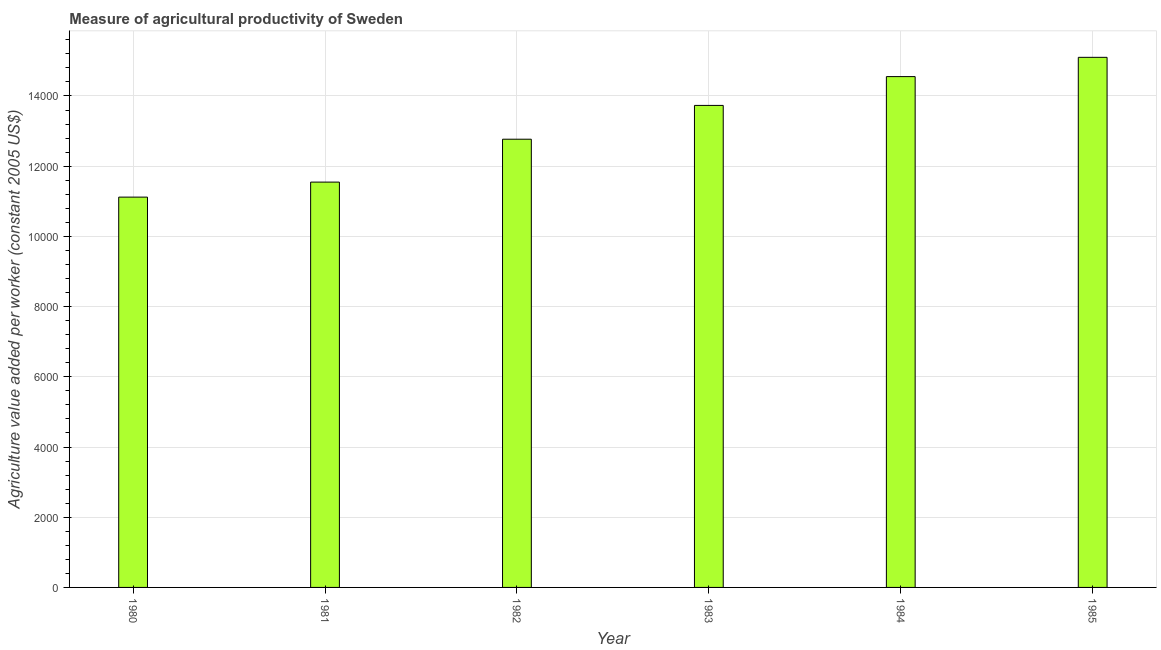What is the title of the graph?
Offer a very short reply. Measure of agricultural productivity of Sweden. What is the label or title of the Y-axis?
Give a very brief answer. Agriculture value added per worker (constant 2005 US$). What is the agriculture value added per worker in 1981?
Offer a terse response. 1.15e+04. Across all years, what is the maximum agriculture value added per worker?
Offer a very short reply. 1.51e+04. Across all years, what is the minimum agriculture value added per worker?
Your answer should be very brief. 1.11e+04. What is the sum of the agriculture value added per worker?
Give a very brief answer. 7.88e+04. What is the difference between the agriculture value added per worker in 1983 and 1985?
Provide a succinct answer. -1369.77. What is the average agriculture value added per worker per year?
Ensure brevity in your answer.  1.31e+04. What is the median agriculture value added per worker?
Make the answer very short. 1.32e+04. Do a majority of the years between 1984 and 1985 (inclusive) have agriculture value added per worker greater than 8400 US$?
Give a very brief answer. Yes. What is the ratio of the agriculture value added per worker in 1982 to that in 1985?
Offer a terse response. 0.85. What is the difference between the highest and the second highest agriculture value added per worker?
Give a very brief answer. 549.02. What is the difference between the highest and the lowest agriculture value added per worker?
Make the answer very short. 3982.16. In how many years, is the agriculture value added per worker greater than the average agriculture value added per worker taken over all years?
Your answer should be very brief. 3. What is the Agriculture value added per worker (constant 2005 US$) of 1980?
Offer a very short reply. 1.11e+04. What is the Agriculture value added per worker (constant 2005 US$) in 1981?
Your answer should be very brief. 1.15e+04. What is the Agriculture value added per worker (constant 2005 US$) of 1982?
Give a very brief answer. 1.28e+04. What is the Agriculture value added per worker (constant 2005 US$) of 1983?
Keep it short and to the point. 1.37e+04. What is the Agriculture value added per worker (constant 2005 US$) in 1984?
Your answer should be very brief. 1.46e+04. What is the Agriculture value added per worker (constant 2005 US$) in 1985?
Your response must be concise. 1.51e+04. What is the difference between the Agriculture value added per worker (constant 2005 US$) in 1980 and 1981?
Keep it short and to the point. -427.51. What is the difference between the Agriculture value added per worker (constant 2005 US$) in 1980 and 1982?
Your answer should be compact. -1649.43. What is the difference between the Agriculture value added per worker (constant 2005 US$) in 1980 and 1983?
Ensure brevity in your answer.  -2612.39. What is the difference between the Agriculture value added per worker (constant 2005 US$) in 1980 and 1984?
Keep it short and to the point. -3433.14. What is the difference between the Agriculture value added per worker (constant 2005 US$) in 1980 and 1985?
Provide a short and direct response. -3982.16. What is the difference between the Agriculture value added per worker (constant 2005 US$) in 1981 and 1982?
Your response must be concise. -1221.92. What is the difference between the Agriculture value added per worker (constant 2005 US$) in 1981 and 1983?
Make the answer very short. -2184.88. What is the difference between the Agriculture value added per worker (constant 2005 US$) in 1981 and 1984?
Provide a short and direct response. -3005.63. What is the difference between the Agriculture value added per worker (constant 2005 US$) in 1981 and 1985?
Provide a succinct answer. -3554.65. What is the difference between the Agriculture value added per worker (constant 2005 US$) in 1982 and 1983?
Offer a very short reply. -962.96. What is the difference between the Agriculture value added per worker (constant 2005 US$) in 1982 and 1984?
Your answer should be compact. -1783.71. What is the difference between the Agriculture value added per worker (constant 2005 US$) in 1982 and 1985?
Your answer should be very brief. -2332.73. What is the difference between the Agriculture value added per worker (constant 2005 US$) in 1983 and 1984?
Provide a succinct answer. -820.75. What is the difference between the Agriculture value added per worker (constant 2005 US$) in 1983 and 1985?
Provide a short and direct response. -1369.77. What is the difference between the Agriculture value added per worker (constant 2005 US$) in 1984 and 1985?
Keep it short and to the point. -549.02. What is the ratio of the Agriculture value added per worker (constant 2005 US$) in 1980 to that in 1981?
Offer a terse response. 0.96. What is the ratio of the Agriculture value added per worker (constant 2005 US$) in 1980 to that in 1982?
Give a very brief answer. 0.87. What is the ratio of the Agriculture value added per worker (constant 2005 US$) in 1980 to that in 1983?
Your answer should be very brief. 0.81. What is the ratio of the Agriculture value added per worker (constant 2005 US$) in 1980 to that in 1984?
Your answer should be very brief. 0.76. What is the ratio of the Agriculture value added per worker (constant 2005 US$) in 1980 to that in 1985?
Give a very brief answer. 0.74. What is the ratio of the Agriculture value added per worker (constant 2005 US$) in 1981 to that in 1982?
Your answer should be very brief. 0.9. What is the ratio of the Agriculture value added per worker (constant 2005 US$) in 1981 to that in 1983?
Provide a succinct answer. 0.84. What is the ratio of the Agriculture value added per worker (constant 2005 US$) in 1981 to that in 1984?
Make the answer very short. 0.79. What is the ratio of the Agriculture value added per worker (constant 2005 US$) in 1981 to that in 1985?
Provide a short and direct response. 0.77. What is the ratio of the Agriculture value added per worker (constant 2005 US$) in 1982 to that in 1983?
Your response must be concise. 0.93. What is the ratio of the Agriculture value added per worker (constant 2005 US$) in 1982 to that in 1984?
Offer a terse response. 0.88. What is the ratio of the Agriculture value added per worker (constant 2005 US$) in 1982 to that in 1985?
Provide a short and direct response. 0.85. What is the ratio of the Agriculture value added per worker (constant 2005 US$) in 1983 to that in 1984?
Keep it short and to the point. 0.94. What is the ratio of the Agriculture value added per worker (constant 2005 US$) in 1983 to that in 1985?
Your answer should be compact. 0.91. What is the ratio of the Agriculture value added per worker (constant 2005 US$) in 1984 to that in 1985?
Make the answer very short. 0.96. 